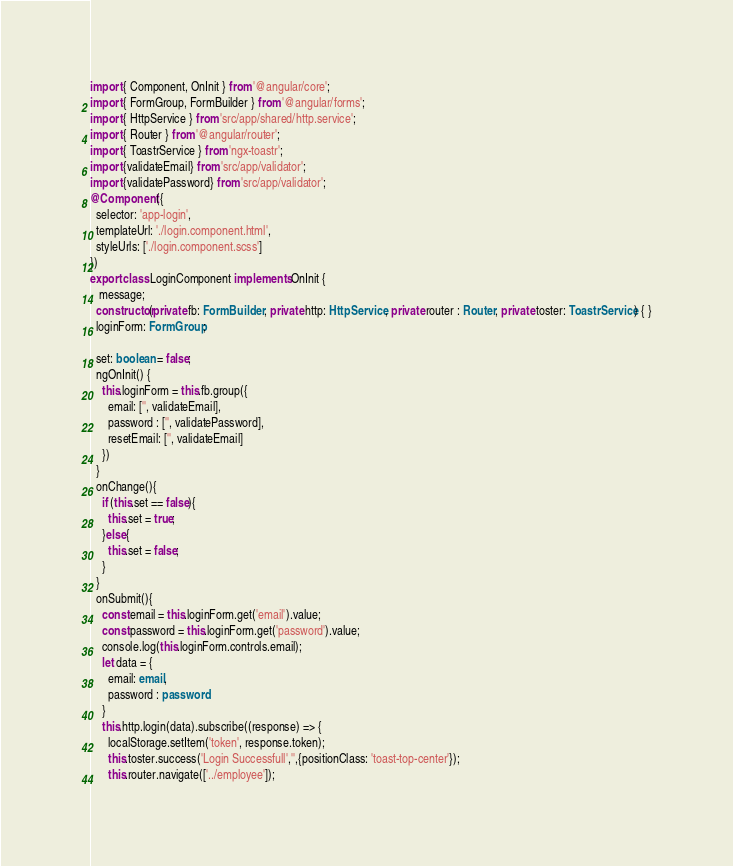<code> <loc_0><loc_0><loc_500><loc_500><_TypeScript_>import { Component, OnInit } from '@angular/core';
import { FormGroup, FormBuilder } from '@angular/forms';
import { HttpService } from 'src/app/shared/http.service';
import { Router } from '@angular/router';
import { ToastrService } from 'ngx-toastr';
import {validateEmail} from 'src/app/validator';
import {validatePassword} from 'src/app/validator';
@Component({
  selector: 'app-login',
  templateUrl: './login.component.html',
  styleUrls: ['./login.component.scss']
})
export class LoginComponent implements OnInit {
   message;
  constructor(private fb: FormBuilder , private http: HttpService, private router : Router, private toster: ToastrService) { }
  loginForm: FormGroup;

  set: boolean = false;
  ngOnInit() {
    this.loginForm = this.fb.group({
      email: ['', validateEmail],
      password : ['', validatePassword],
      resetEmail: ['', validateEmail]
    })
  }
  onChange(){
    if (this.set == false){
      this.set = true;
    }else{
      this.set = false;
    }
  }
  onSubmit(){
    const email = this.loginForm.get('email').value;
    const password = this.loginForm.get('password').value;
    console.log(this.loginForm.controls.email);
    let data = {
      email: email,
      password : password
    }
    this.http.login(data).subscribe((response) => {
      localStorage.setItem('token', response.token);
      this.toster.success('Login Successfull','',{positionClass: 'toast-top-center'});
      this.router.navigate(['../employee']);</code> 